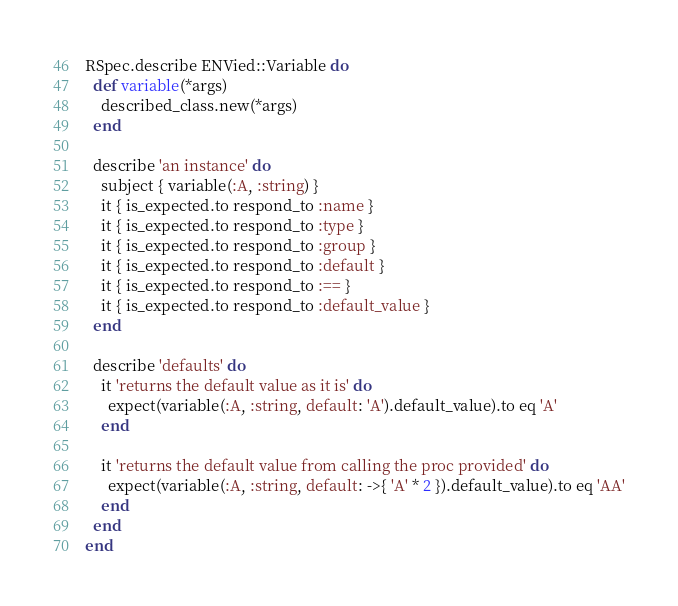Convert code to text. <code><loc_0><loc_0><loc_500><loc_500><_Ruby_>RSpec.describe ENVied::Variable do
  def variable(*args)
    described_class.new(*args)
  end

  describe 'an instance' do
    subject { variable(:A, :string) }
    it { is_expected.to respond_to :name }
    it { is_expected.to respond_to :type }
    it { is_expected.to respond_to :group }
    it { is_expected.to respond_to :default }
    it { is_expected.to respond_to :== }
    it { is_expected.to respond_to :default_value }
  end

  describe 'defaults' do
    it 'returns the default value as it is' do
      expect(variable(:A, :string, default: 'A').default_value).to eq 'A'
    end

    it 'returns the default value from calling the proc provided' do
      expect(variable(:A, :string, default: ->{ 'A' * 2 }).default_value).to eq 'AA'
    end
  end
end
</code> 